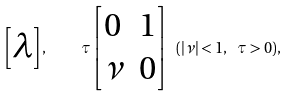<formula> <loc_0><loc_0><loc_500><loc_500>\begin{bmatrix} \lambda \end{bmatrix} , \quad \tau \begin{bmatrix} 0 & 1 \\ \nu & 0 \end{bmatrix} \ ( | \nu | < 1 , \ \tau > 0 ) ,</formula> 